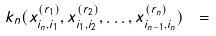Convert formula to latex. <formula><loc_0><loc_0><loc_500><loc_500>k _ { n } ( x _ { i _ { n } , i _ { 1 } } ^ { ( r _ { 1 } ) } , x _ { i _ { 1 } , i _ { 2 } } ^ { ( r _ { 2 } ) } , \dots , x _ { i _ { n - 1 } , i _ { n } } ^ { ( r _ { n } ) } ) \ =</formula> 